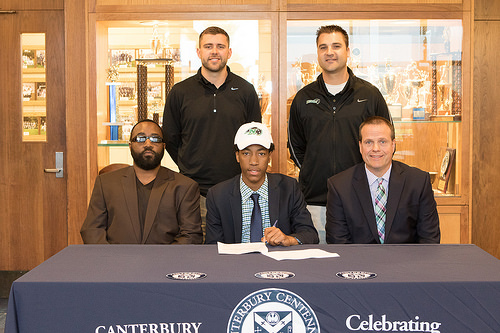<image>
Can you confirm if the table is next to the man? No. The table is not positioned next to the man. They are located in different areas of the scene. Is the man above the table? No. The man is not positioned above the table. The vertical arrangement shows a different relationship. 